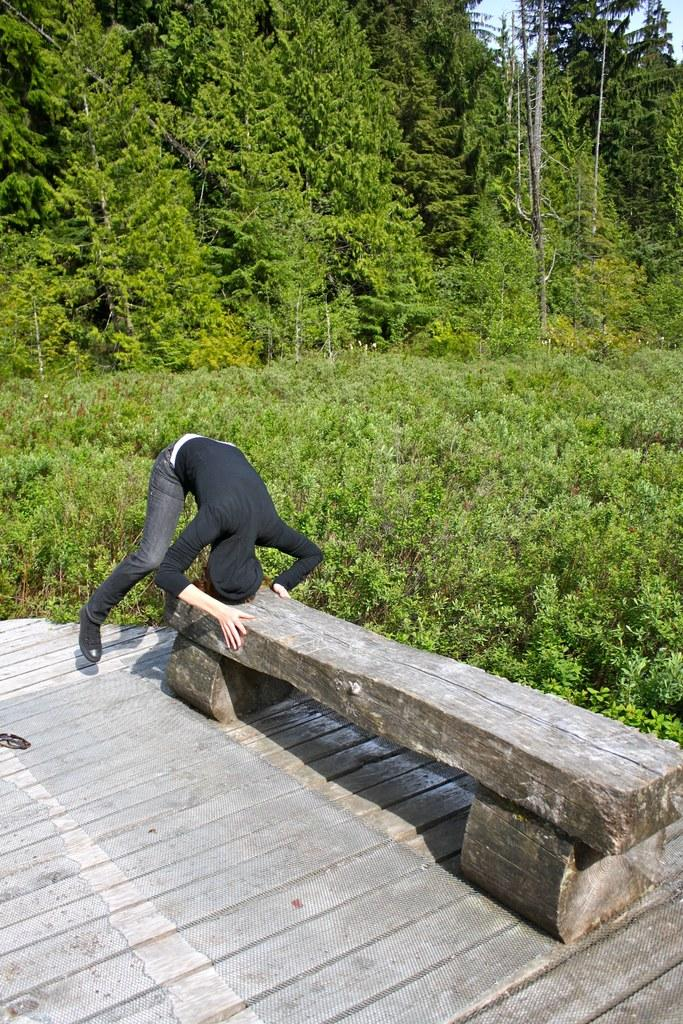What is the main subject of the image? There is a person in the image. What is the person doing in the image? The person is putting their head on a wooden bench. What type of plants can be seen in the image? There are green color plants in the image. What can be seen in the background of the image? There are green color trees in the background of the image. What type of soap is the person using to clean the wooden bench in the image? There is no soap present in the image, and the person is not cleaning the wooden bench. 